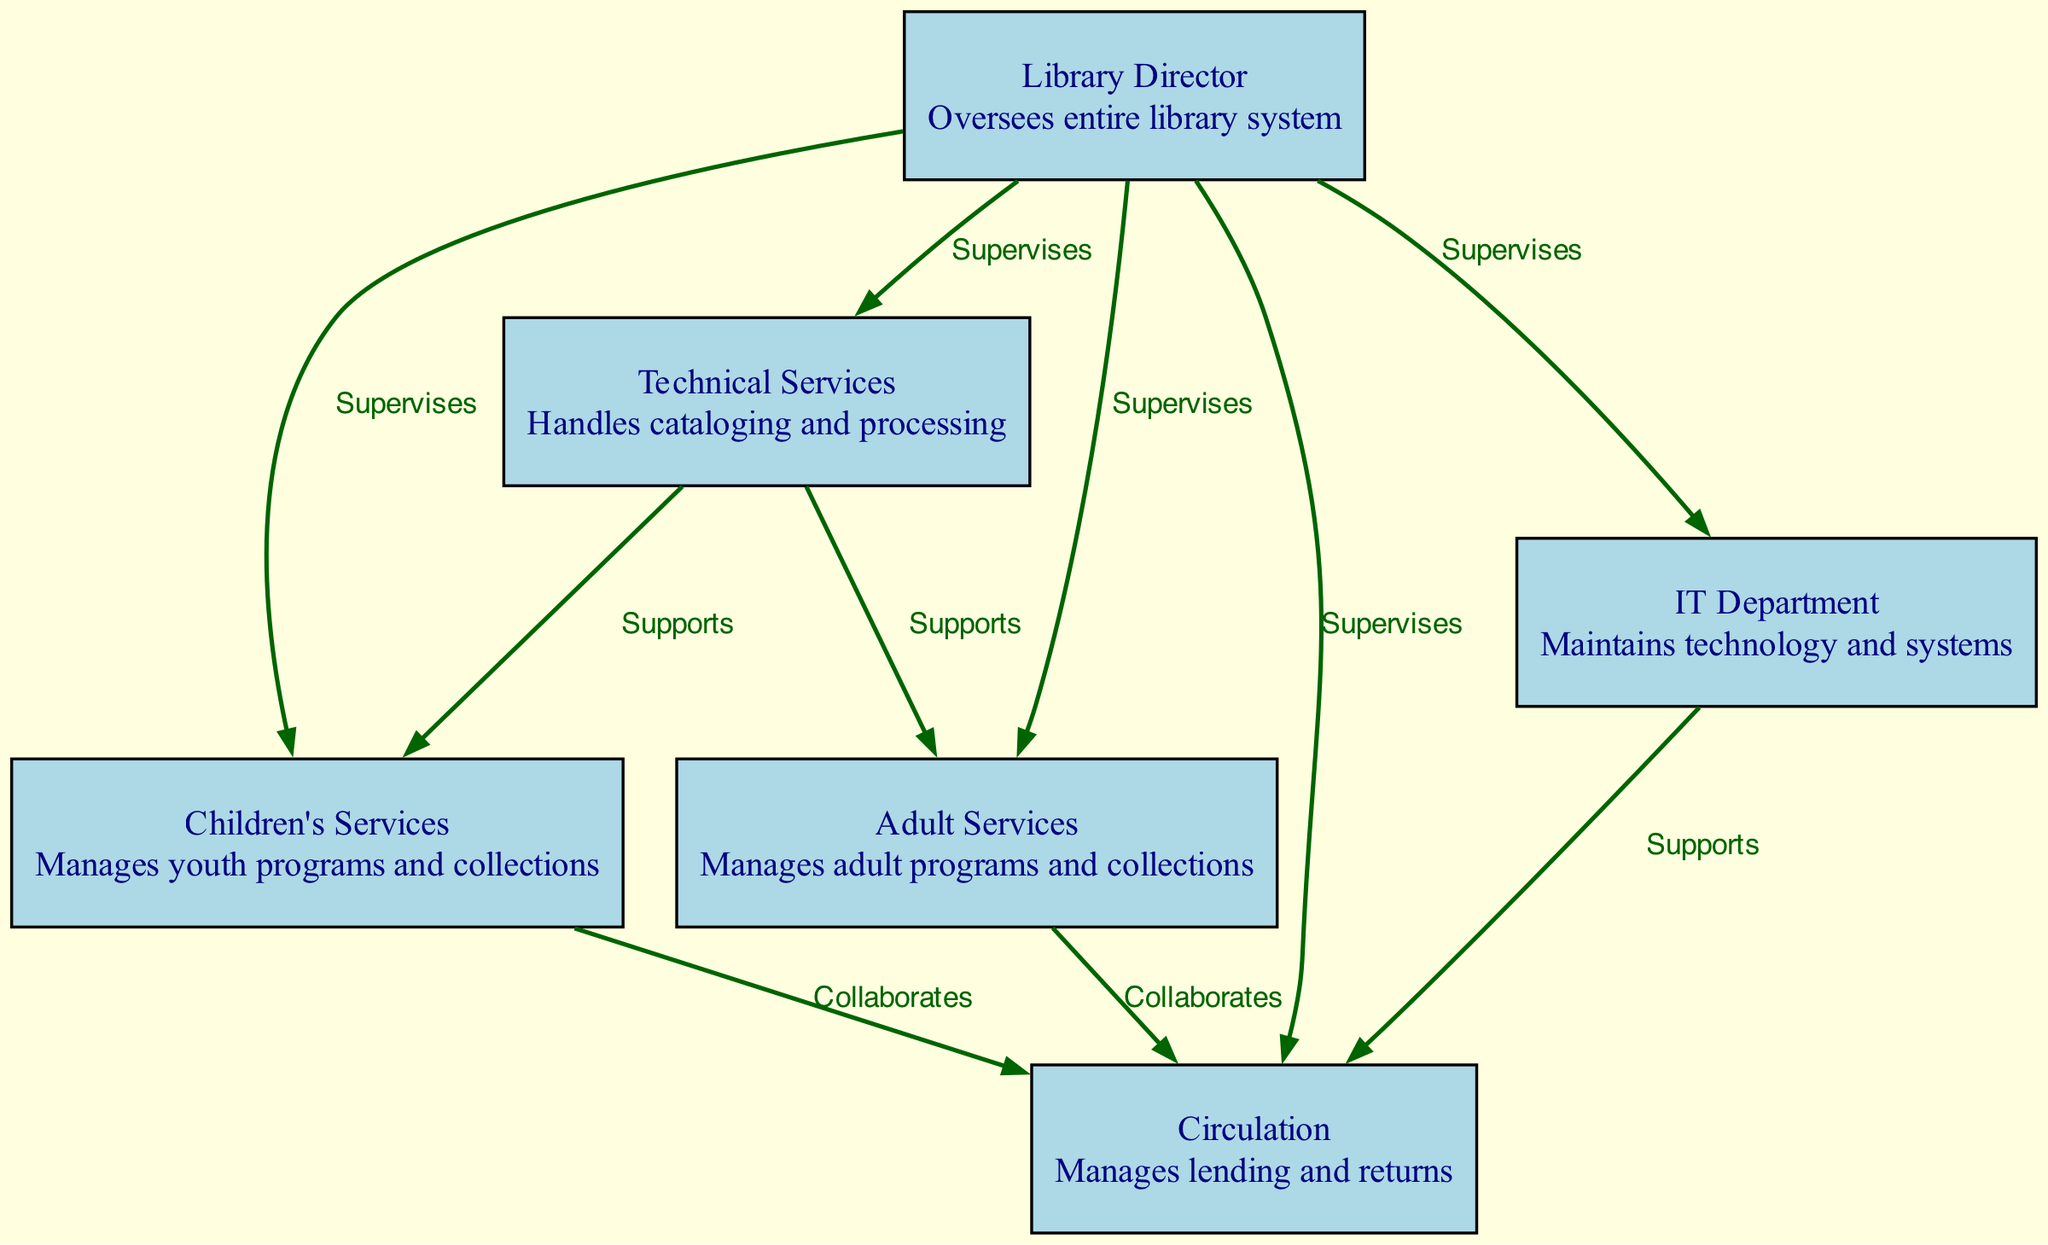What is the role responsible for overseeing the entire library system? The diagram shows that the "Library Director" is the only node with the description "Oversees entire library system." Therefore, the role responsible is the Library Director.
Answer: Library Director How many departments collaborate with the Circulation department? By examining the edges, the Circulation department has connections labeled "Collaborates" with both the Children's Services and Adult Services departments. This indicates that there are two departments that collaborate with Circulation.
Answer: 2 Which department is supported by both the Technical Services and IT Department? The diagram indicates that the Technical Services department "Supports" the Children's Services and Adult Services departments, while the IT Department "Supports" the Circulation department. The only overlap in supported departments is with the Circulation department, thus leading to the conclusion that the department supported by both is Circulation.
Answer: Circulation What is the relationship between Technical Services and the Children's Services? The diagram shows an edge labeled "Supports" connecting Technical Services to Children's Services. This indicates that the relationship is one where Technical Services provides support to Children's Services.
Answer: Supports How many nodes are there in the diagram? The total number of nodes can be counted directly from the provided data. There are six nodes representing different roles and departments in the public library system. Thus, the answer is 6.
Answer: 6 Which role does not have any direct collaborations with the Circulation department? Looking at the edges, both Children's Services and Adult Services directly collaborate with the Circulation department. However, the Technical Services department does not have a direct collaborative connection to Circulation, making it the answer.
Answer: Technical Services What department does the Library Director supervise? The diagram indicates that the Library Director supervises multiple departments. A quick scan shows the edges leading from the director to Children's Services, Adult Services, Technical Services, Circulation, and IT Department, thus confirming that all mentioned departments are supervised.
Answer: All departments What is the relationship between Adult Services and Technical Services? The diagram specifies that Adult Services does not have a direct relationship with Technical Services listed as "Supervises" or "Collaborates," although Technical Services does "Support" Adult Services. Hence, the relationship is supportive.
Answer: Supports 